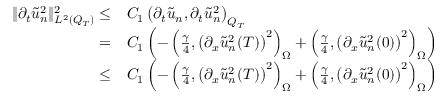<formula> <loc_0><loc_0><loc_500><loc_500>\begin{array} { r l } { \| \partial _ { t } \tilde { u } _ { n } ^ { 2 } \| _ { L ^ { 2 } ( Q _ { T } ) } ^ { 2 } \leq } & C _ { 1 } \left ( \partial _ { t } \tilde { u } _ { n } , \partial _ { t } \tilde { u } _ { n } ^ { 2 } \right ) _ { Q _ { T } } } \\ { = } & C _ { 1 } \left ( - \left ( \frac { \gamma } { 4 } , \left ( \partial _ { x } \tilde { u } _ { n } ^ { 2 } ( T ) \right ) ^ { 2 } \right ) _ { \Omega } + \left ( \frac { \gamma } { 4 } , \left ( \partial _ { x } \tilde { u } _ { n } ^ { 2 } ( 0 ) \right ) ^ { 2 } \right ) _ { \Omega } \right ) } \\ { \leq } & C _ { 1 } \left ( - \left ( \frac { \gamma } { 4 } , \left ( \partial _ { x } \tilde { u } _ { n } ^ { 2 } ( T ) \right ) ^ { 2 } \right ) _ { \Omega } + \left ( \frac { \gamma } { 4 } , \left ( \partial _ { x } \tilde { u } _ { n } ^ { 2 } ( 0 ) \right ) ^ { 2 } \right ) _ { \Omega } \right ) } \end{array}</formula> 